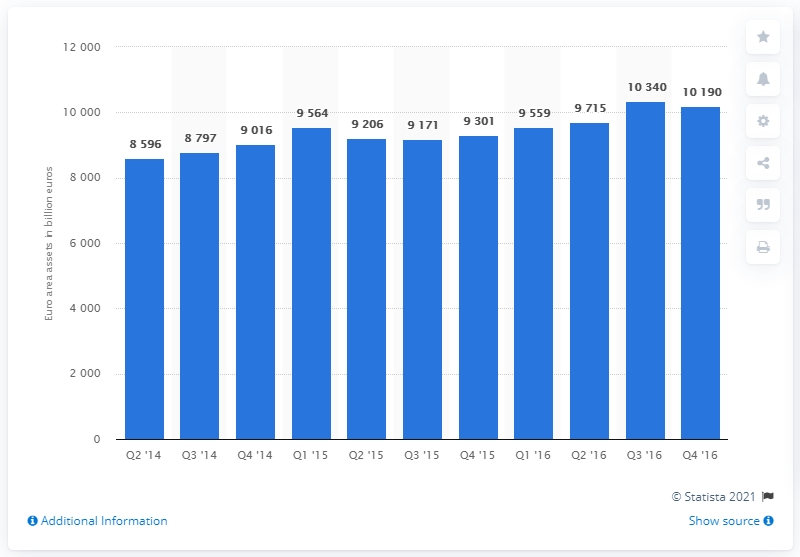List a handful of essential elements in this visual. As of the fourth quarter of 2016, the total assets of insurance corporations and pension funds were 10,340. 